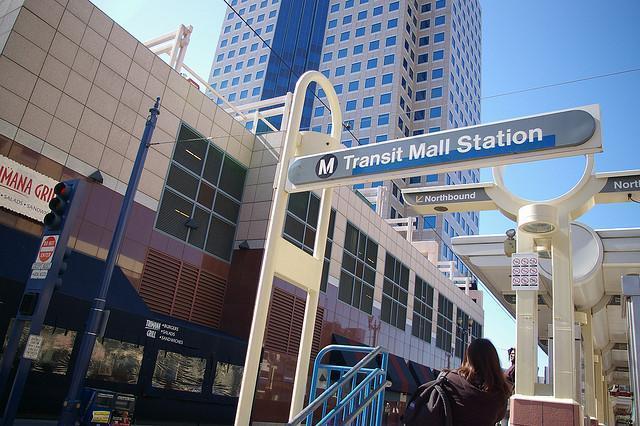What color is the light all the way to the left?
Select the accurate answer and provide explanation: 'Answer: answer
Rationale: rationale.'
Options: Blue, green, yellow, red. Answer: red.
Rationale: The light on the left is red colored. 